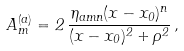<formula> <loc_0><loc_0><loc_500><loc_500>A _ { m } ^ { ( a ) } = 2 \, \frac { \eta _ { a m n } ( x - x _ { 0 } ) ^ { n } } { ( x - x _ { 0 } ) ^ { 2 } + \rho ^ { 2 } } \, ,</formula> 